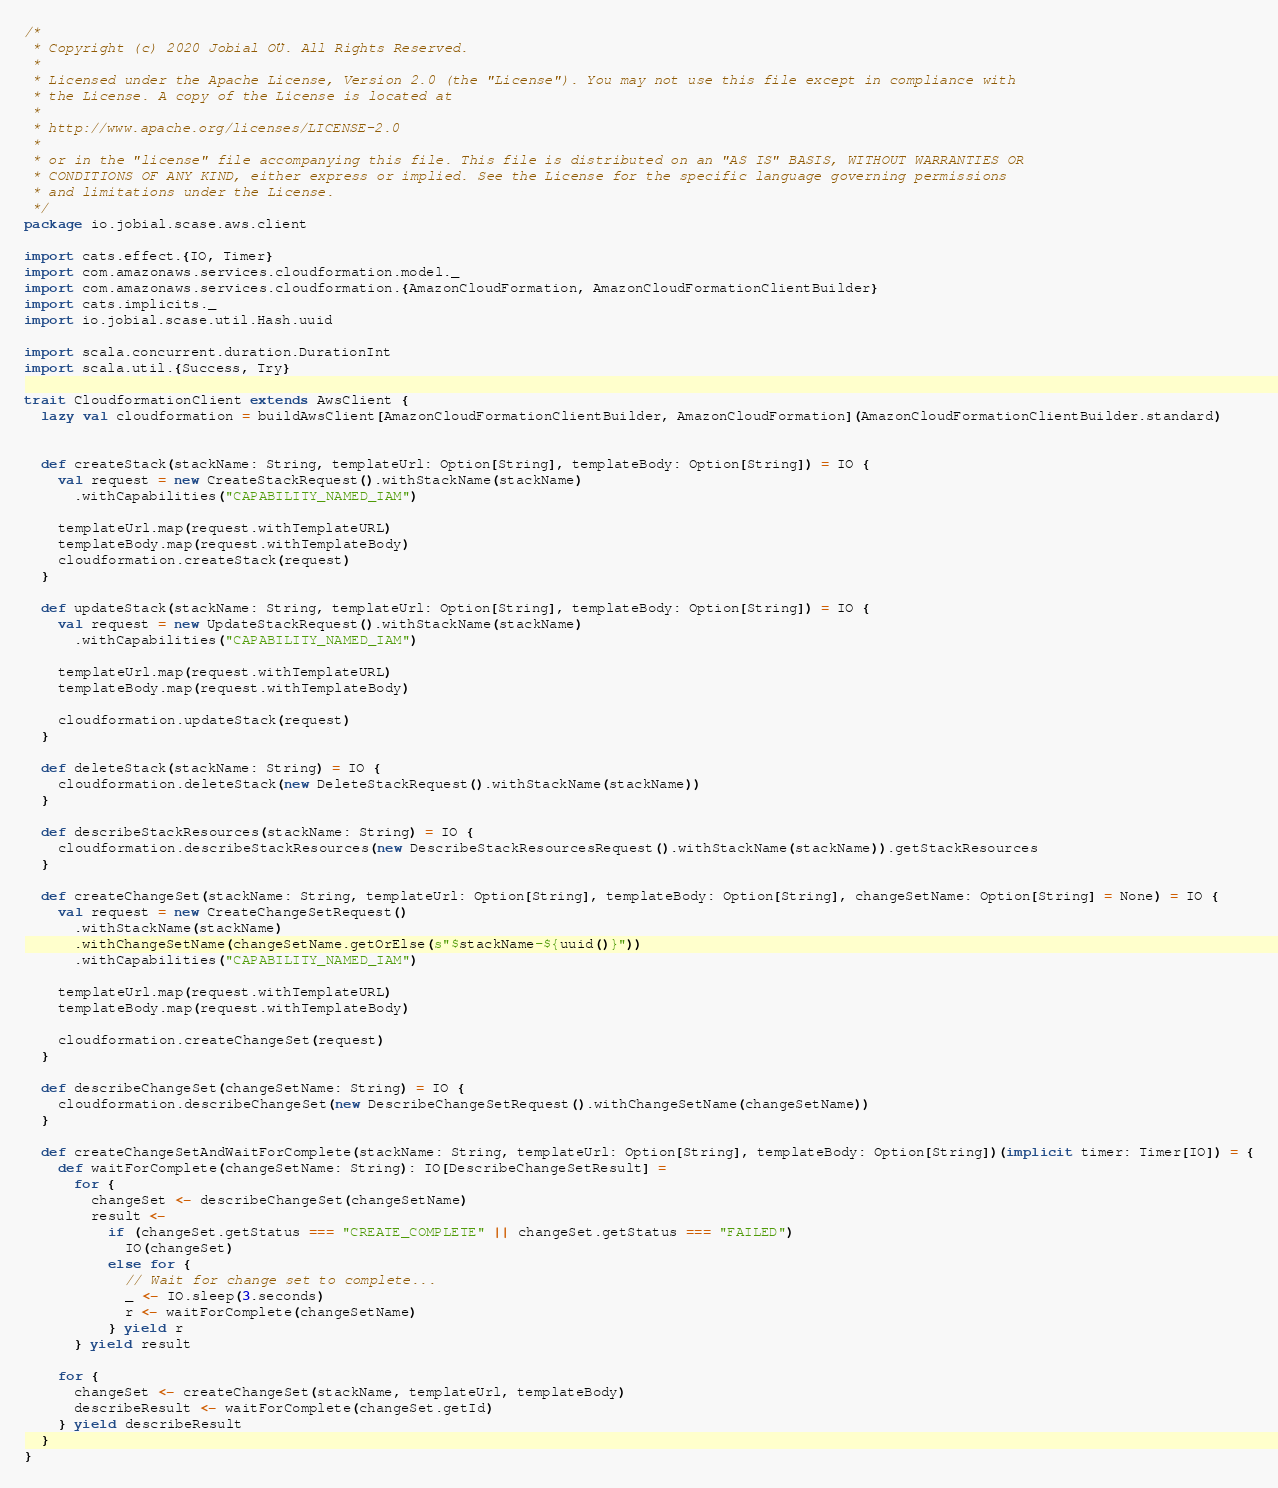Convert code to text. <code><loc_0><loc_0><loc_500><loc_500><_Scala_>/*
 * Copyright (c) 2020 Jobial OÜ. All Rights Reserved.
 *
 * Licensed under the Apache License, Version 2.0 (the "License"). You may not use this file except in compliance with
 * the License. A copy of the License is located at
 * 
 * http://www.apache.org/licenses/LICENSE-2.0
 * 
 * or in the "license" file accompanying this file. This file is distributed on an "AS IS" BASIS, WITHOUT WARRANTIES OR
 * CONDITIONS OF ANY KIND, either express or implied. See the License for the specific language governing permissions
 * and limitations under the License.
 */
package io.jobial.scase.aws.client

import cats.effect.{IO, Timer}
import com.amazonaws.services.cloudformation.model._
import com.amazonaws.services.cloudformation.{AmazonCloudFormation, AmazonCloudFormationClientBuilder}
import cats.implicits._
import io.jobial.scase.util.Hash.uuid

import scala.concurrent.duration.DurationInt
import scala.util.{Success, Try}

trait CloudformationClient extends AwsClient {
  lazy val cloudformation = buildAwsClient[AmazonCloudFormationClientBuilder, AmazonCloudFormation](AmazonCloudFormationClientBuilder.standard)


  def createStack(stackName: String, templateUrl: Option[String], templateBody: Option[String]) = IO {
    val request = new CreateStackRequest().withStackName(stackName)
      .withCapabilities("CAPABILITY_NAMED_IAM")

    templateUrl.map(request.withTemplateURL)
    templateBody.map(request.withTemplateBody)
    cloudformation.createStack(request)
  }

  def updateStack(stackName: String, templateUrl: Option[String], templateBody: Option[String]) = IO {
    val request = new UpdateStackRequest().withStackName(stackName)
      .withCapabilities("CAPABILITY_NAMED_IAM")

    templateUrl.map(request.withTemplateURL)
    templateBody.map(request.withTemplateBody)

    cloudformation.updateStack(request)
  }

  def deleteStack(stackName: String) = IO {
    cloudformation.deleteStack(new DeleteStackRequest().withStackName(stackName))
  }

  def describeStackResources(stackName: String) = IO {
    cloudformation.describeStackResources(new DescribeStackResourcesRequest().withStackName(stackName)).getStackResources
  }

  def createChangeSet(stackName: String, templateUrl: Option[String], templateBody: Option[String], changeSetName: Option[String] = None) = IO {
    val request = new CreateChangeSetRequest()
      .withStackName(stackName)
      .withChangeSetName(changeSetName.getOrElse(s"$stackName-${uuid()}"))
      .withCapabilities("CAPABILITY_NAMED_IAM")

    templateUrl.map(request.withTemplateURL)
    templateBody.map(request.withTemplateBody)

    cloudformation.createChangeSet(request)
  }

  def describeChangeSet(changeSetName: String) = IO {
    cloudformation.describeChangeSet(new DescribeChangeSetRequest().withChangeSetName(changeSetName))
  }

  def createChangeSetAndWaitForComplete(stackName: String, templateUrl: Option[String], templateBody: Option[String])(implicit timer: Timer[IO]) = {
    def waitForComplete(changeSetName: String): IO[DescribeChangeSetResult] =
      for {
        changeSet <- describeChangeSet(changeSetName)
        result <-
          if (changeSet.getStatus === "CREATE_COMPLETE" || changeSet.getStatus === "FAILED")
            IO(changeSet)
          else for {
            // Wait for change set to complete...
            _ <- IO.sleep(3.seconds)
            r <- waitForComplete(changeSetName)
          } yield r
      } yield result

    for {
      changeSet <- createChangeSet(stackName, templateUrl, templateBody)
      describeResult <- waitForComplete(changeSet.getId)
    } yield describeResult
  }
}
</code> 